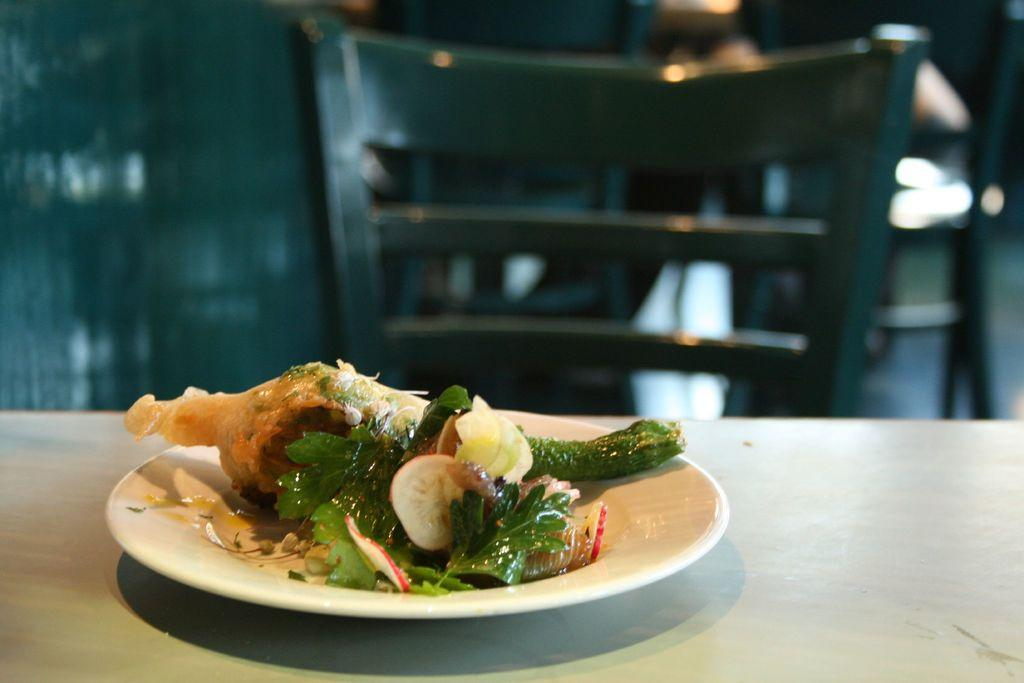What is on the plate that is visible in the image? There is food in a plate in the image. What is the plate resting on? The plate is on an object. What type of furniture is behind the plate? There is a chair behind the plate. Can you describe the background of the image? The background of the image is blurred. How many flowers are on the plate in the image? There are no flowers present on the plate in the image; it contains food. 